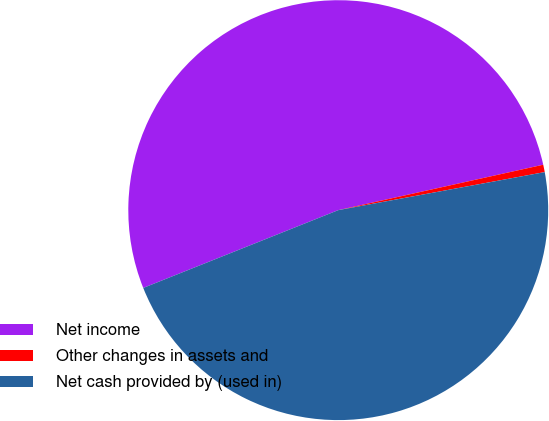Convert chart. <chart><loc_0><loc_0><loc_500><loc_500><pie_chart><fcel>Net income<fcel>Other changes in assets and<fcel>Net cash provided by (used in)<nl><fcel>52.57%<fcel>0.57%<fcel>46.86%<nl></chart> 